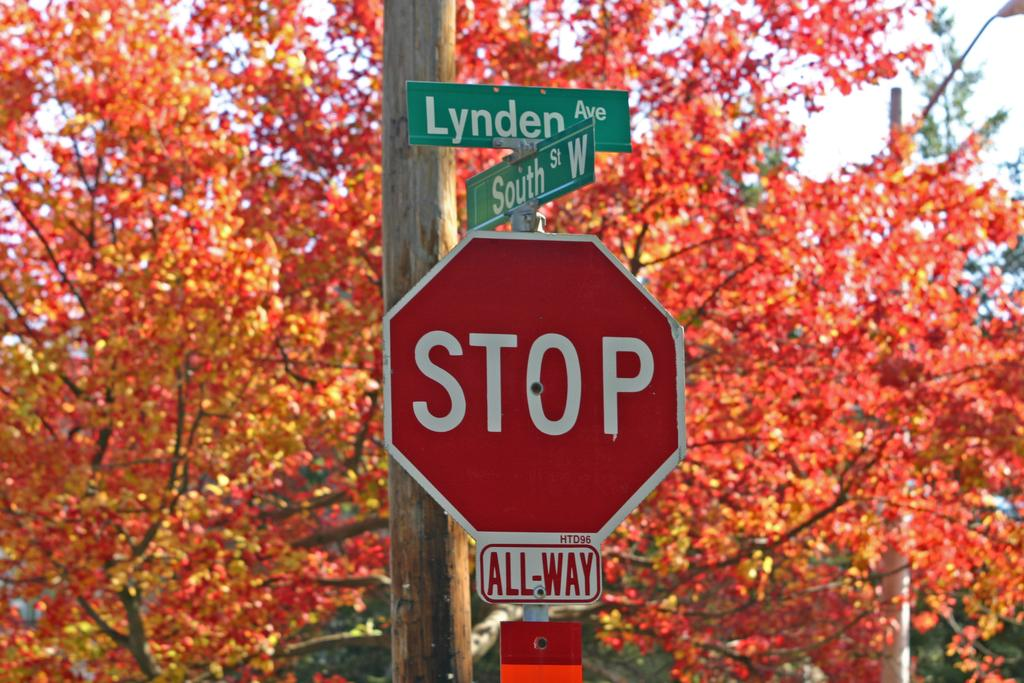<image>
Provide a brief description of the given image. A stop sign is in front of a bright orange tree. 